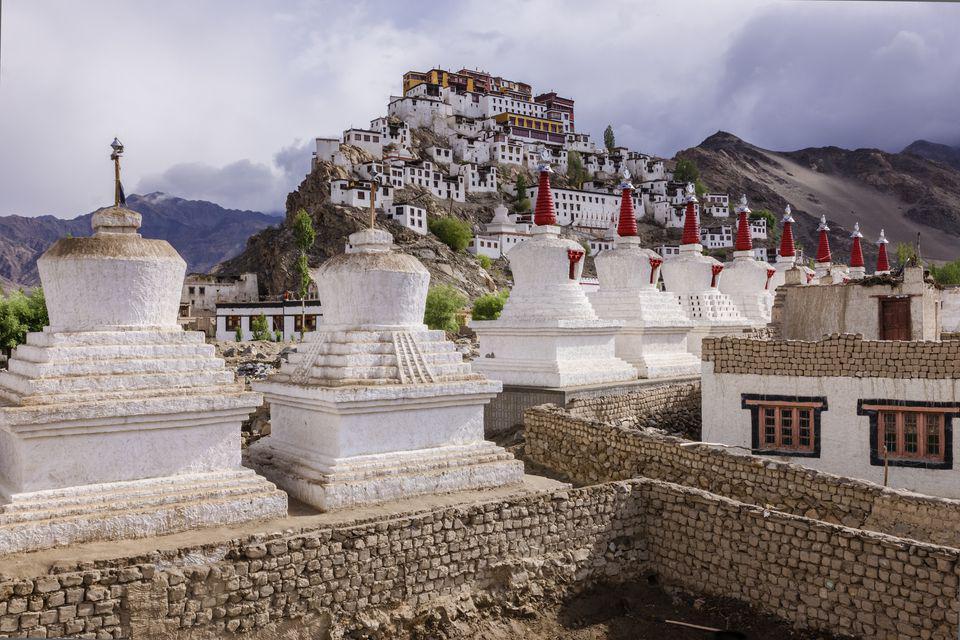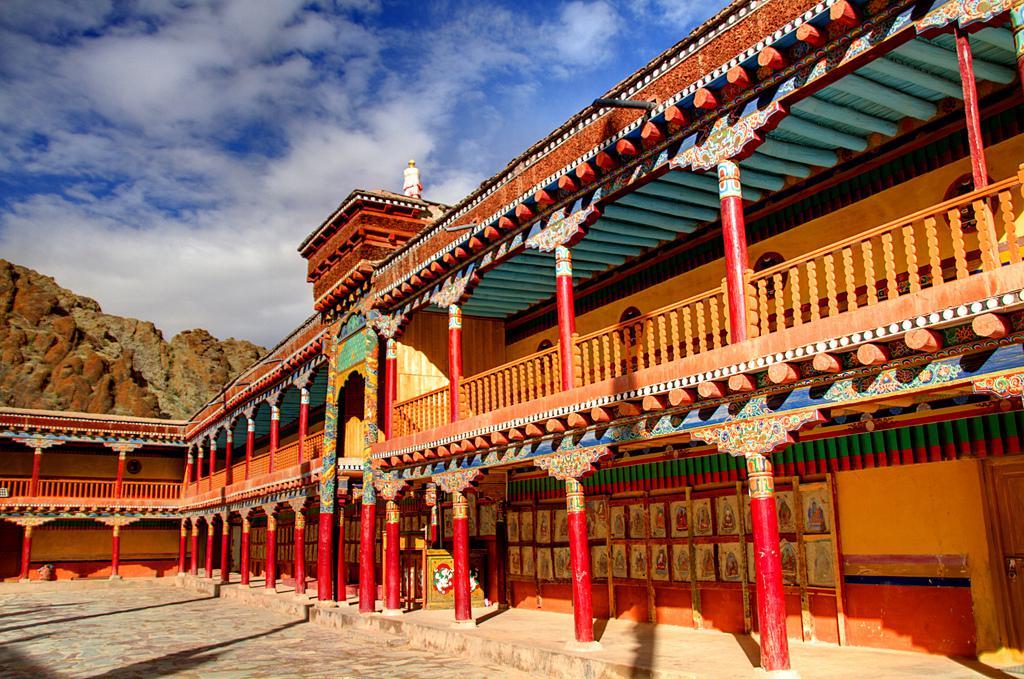The first image is the image on the left, the second image is the image on the right. Assess this claim about the two images: "An image shows a temple with a line of red-bottomed columns along its front, and an empty lot in front of it.". Correct or not? Answer yes or no. Yes. The first image is the image on the left, the second image is the image on the right. For the images displayed, is the sentence "One building has gray stone material, the other does not." factually correct? Answer yes or no. Yes. 